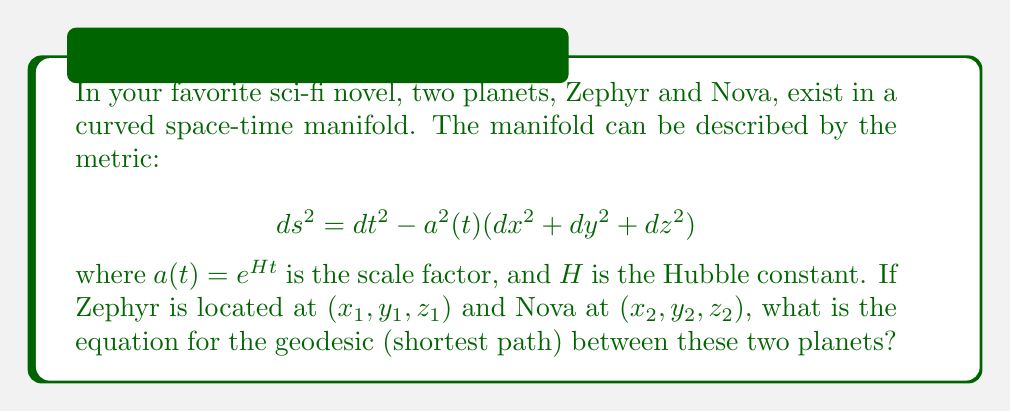Help me with this question. To find the geodesic between the two planets, we need to use the Euler-Lagrange equations from the calculus of variations. Here's the step-by-step process:

1) First, we need to write the Lagrangian for this metric:

   $$L = \sqrt{\dot{t}^2 - a^2(t)(\dot{x}^2 + \dot{y}^2 + \dot{z}^2)}$$

   where dots represent derivatives with respect to some parameter $\lambda$.

2) The Euler-Lagrange equations are:

   $$\frac{d}{d\lambda}\left(\frac{\partial L}{\partial \dot{q}_i}\right) - \frac{\partial L}{\partial q_i} = 0$$

   for each coordinate $q_i = t, x, y, z$.

3) For the $t$ coordinate:

   $$\frac{d}{d\lambda}\left(\frac{\dot{t}}{L}\right) + \frac{a\dot{a}}{L}(\dot{x}^2 + \dot{y}^2 + \dot{z}^2) = 0$$

4) For the spatial coordinates ($x$ shown, $y$ and $z$ are similar):

   $$\frac{d}{d\lambda}\left(\frac{a^2\dot{x}}{L}\right) = 0$$

5) From the spatial equations, we can deduce:

   $$\frac{a^2\dot{x}}{L} = c_x, \frac{a^2\dot{y}}{L} = c_y, \frac{a^2\dot{z}}{L} = c_z$$

   where $c_x, c_y, c_z$ are constants.

6) Substituting these into the metric equation:

   $$1 = \frac{\dot{t}^2}{L^2} - \frac{1}{a^2}\left(c_x^2 + c_y^2 + c_z^2\right)$$

7) Solving for $\dot{t}$:

   $$\dot{t} = \sqrt{L^2 + \frac{L^2}{a^2}\left(c_x^2 + c_y^2 + c_z^2\right)}$$

8) The geodesic equation can be written as:

   $$\frac{dx}{dt} = \frac{\dot{x}}{\dot{t}} = \frac{c_x}{a^2\sqrt{1 + \frac{c_x^2 + c_y^2 + c_z^2}{a^2}}}$$

   (Similar equations for $y$ and $z$)

This set of differential equations describes the geodesic between the two planets.
Answer: $$\frac{dx}{dt} = \frac{c_x}{a^2\sqrt{1 + \frac{c_x^2 + c_y^2 + c_z^2}{a^2}}}$$ 